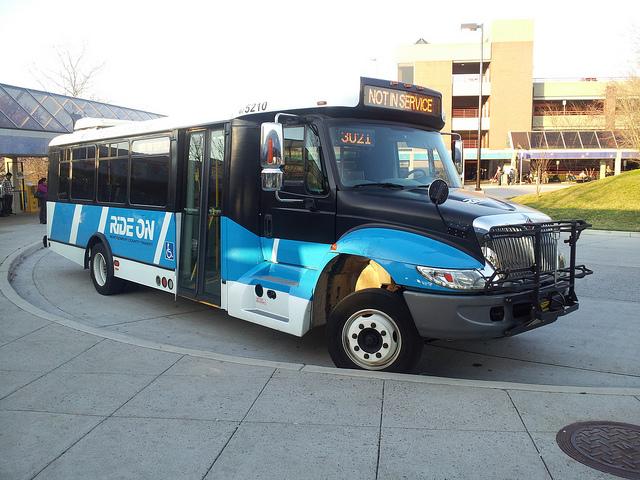Is this bus in service?
Keep it brief. No. There are 7 rectangles on the upper-right side; what do they do?
Quick response, please. Let in light. What large number is visible?
Write a very short answer. 3021. Is the wind blowing to the right?
Write a very short answer. No. Is the bus parked?
Be succinct. Yes. What kind of vehicle is shown?
Be succinct. Bus. 